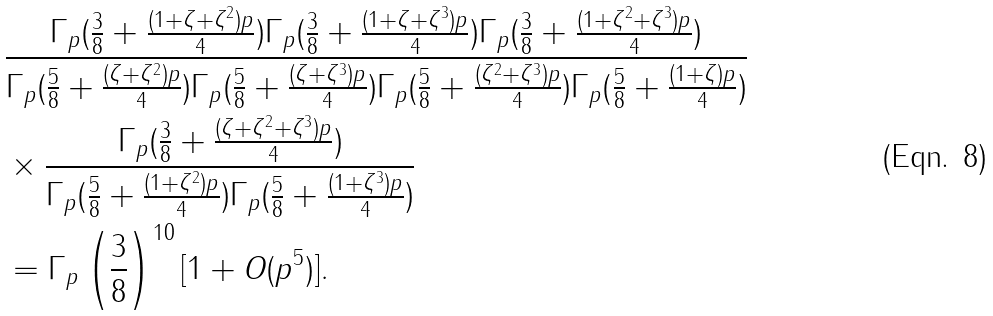Convert formula to latex. <formula><loc_0><loc_0><loc_500><loc_500>& \frac { \Gamma _ { p } ( \frac { 3 } { 8 } + \frac { ( 1 + \zeta + \zeta ^ { 2 } ) p } { 4 } ) \Gamma _ { p } ( \frac { 3 } { 8 } + \frac { ( 1 + \zeta + \zeta ^ { 3 } ) p } { 4 } ) \Gamma _ { p } ( \frac { 3 } { 8 } + \frac { ( 1 + \zeta ^ { 2 } + \zeta ^ { 3 } ) p } { 4 } ) } { \Gamma _ { p } ( \frac { 5 } { 8 } + \frac { ( \zeta + \zeta ^ { 2 } ) p } { 4 } ) \Gamma _ { p } ( \frac { 5 } { 8 } + \frac { ( \zeta + \zeta ^ { 3 } ) p } { 4 } ) \Gamma _ { p } ( \frac { 5 } { 8 } + \frac { ( \zeta ^ { 2 } + \zeta ^ { 3 } ) p } { 4 } ) \Gamma _ { p } ( \frac { 5 } { 8 } + \frac { ( 1 + \zeta ) p } { 4 } ) } \\ & \times \frac { \Gamma _ { p } ( \frac { 3 } { 8 } + \frac { ( \zeta + \zeta ^ { 2 } + \zeta ^ { 3 } ) p } { 4 } ) } { \Gamma _ { p } ( \frac { 5 } { 8 } + \frac { ( 1 + \zeta ^ { 2 } ) p } { 4 } ) \Gamma _ { p } ( \frac { 5 } { 8 } + \frac { ( 1 + \zeta ^ { 3 } ) p } { 4 } ) } \\ & = \Gamma _ { p } \left ( \frac { 3 } { 8 } \right ) ^ { 1 0 } [ 1 + O ( p ^ { 5 } ) ] .</formula> 